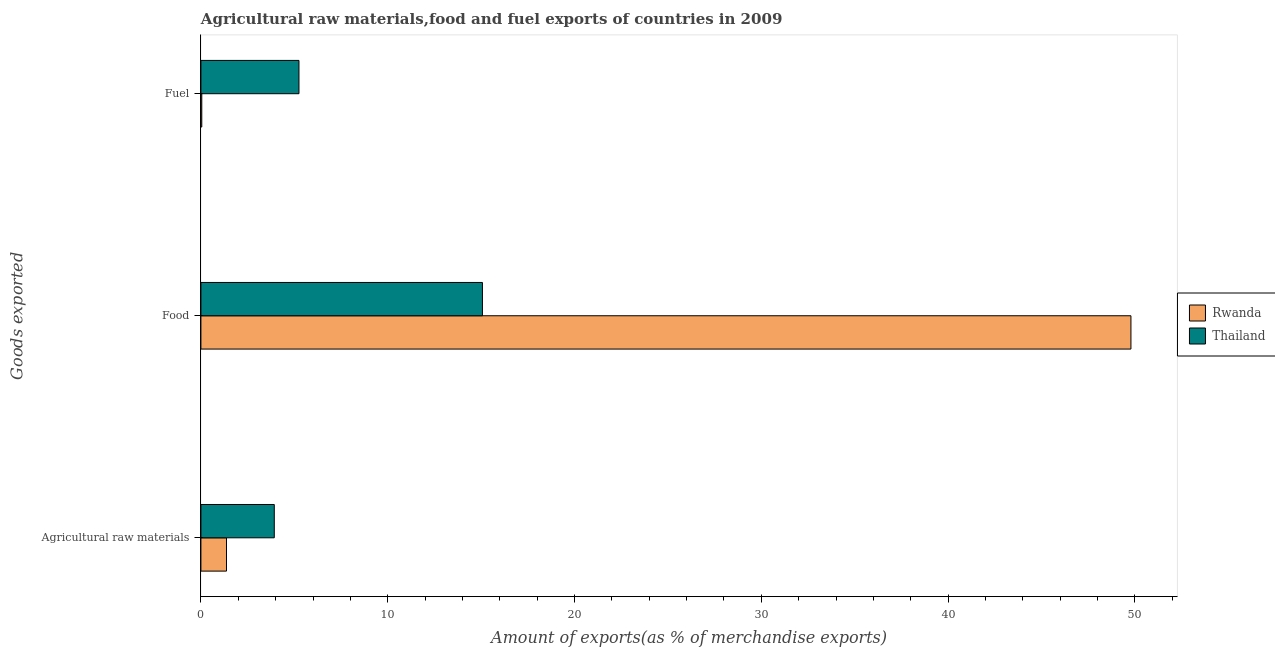How many different coloured bars are there?
Your answer should be very brief. 2. How many bars are there on the 2nd tick from the top?
Give a very brief answer. 2. How many bars are there on the 2nd tick from the bottom?
Offer a very short reply. 2. What is the label of the 1st group of bars from the top?
Keep it short and to the point. Fuel. What is the percentage of raw materials exports in Thailand?
Your response must be concise. 3.93. Across all countries, what is the maximum percentage of raw materials exports?
Ensure brevity in your answer.  3.93. Across all countries, what is the minimum percentage of food exports?
Provide a short and direct response. 15.07. In which country was the percentage of raw materials exports maximum?
Ensure brevity in your answer.  Thailand. In which country was the percentage of fuel exports minimum?
Offer a very short reply. Rwanda. What is the total percentage of food exports in the graph?
Ensure brevity in your answer.  64.86. What is the difference between the percentage of food exports in Rwanda and that in Thailand?
Your answer should be compact. 34.72. What is the difference between the percentage of raw materials exports in Rwanda and the percentage of food exports in Thailand?
Your answer should be compact. -13.7. What is the average percentage of fuel exports per country?
Keep it short and to the point. 2.65. What is the difference between the percentage of raw materials exports and percentage of fuel exports in Thailand?
Give a very brief answer. -1.32. In how many countries, is the percentage of food exports greater than 6 %?
Your response must be concise. 2. What is the ratio of the percentage of fuel exports in Rwanda to that in Thailand?
Keep it short and to the point. 0.01. Is the difference between the percentage of raw materials exports in Rwanda and Thailand greater than the difference between the percentage of food exports in Rwanda and Thailand?
Offer a very short reply. No. What is the difference between the highest and the second highest percentage of fuel exports?
Offer a very short reply. 5.2. What is the difference between the highest and the lowest percentage of raw materials exports?
Keep it short and to the point. 2.56. In how many countries, is the percentage of raw materials exports greater than the average percentage of raw materials exports taken over all countries?
Provide a succinct answer. 1. Is the sum of the percentage of fuel exports in Rwanda and Thailand greater than the maximum percentage of raw materials exports across all countries?
Give a very brief answer. Yes. What does the 1st bar from the top in Food represents?
Give a very brief answer. Thailand. What does the 2nd bar from the bottom in Fuel represents?
Make the answer very short. Thailand. Is it the case that in every country, the sum of the percentage of raw materials exports and percentage of food exports is greater than the percentage of fuel exports?
Provide a short and direct response. Yes. Are all the bars in the graph horizontal?
Offer a terse response. Yes. How many countries are there in the graph?
Your answer should be compact. 2. What is the difference between two consecutive major ticks on the X-axis?
Provide a succinct answer. 10. Does the graph contain any zero values?
Your response must be concise. No. Does the graph contain grids?
Offer a very short reply. No. How many legend labels are there?
Offer a very short reply. 2. How are the legend labels stacked?
Offer a terse response. Vertical. What is the title of the graph?
Offer a terse response. Agricultural raw materials,food and fuel exports of countries in 2009. What is the label or title of the X-axis?
Your answer should be very brief. Amount of exports(as % of merchandise exports). What is the label or title of the Y-axis?
Your answer should be compact. Goods exported. What is the Amount of exports(as % of merchandise exports) of Rwanda in Agricultural raw materials?
Offer a terse response. 1.37. What is the Amount of exports(as % of merchandise exports) of Thailand in Agricultural raw materials?
Offer a terse response. 3.93. What is the Amount of exports(as % of merchandise exports) in Rwanda in Food?
Offer a very short reply. 49.79. What is the Amount of exports(as % of merchandise exports) of Thailand in Food?
Make the answer very short. 15.07. What is the Amount of exports(as % of merchandise exports) of Rwanda in Fuel?
Offer a very short reply. 0.05. What is the Amount of exports(as % of merchandise exports) of Thailand in Fuel?
Your answer should be very brief. 5.25. Across all Goods exported, what is the maximum Amount of exports(as % of merchandise exports) in Rwanda?
Ensure brevity in your answer.  49.79. Across all Goods exported, what is the maximum Amount of exports(as % of merchandise exports) in Thailand?
Keep it short and to the point. 15.07. Across all Goods exported, what is the minimum Amount of exports(as % of merchandise exports) in Rwanda?
Make the answer very short. 0.05. Across all Goods exported, what is the minimum Amount of exports(as % of merchandise exports) in Thailand?
Provide a succinct answer. 3.93. What is the total Amount of exports(as % of merchandise exports) in Rwanda in the graph?
Provide a short and direct response. 51.2. What is the total Amount of exports(as % of merchandise exports) of Thailand in the graph?
Keep it short and to the point. 24.25. What is the difference between the Amount of exports(as % of merchandise exports) in Rwanda in Agricultural raw materials and that in Food?
Your answer should be very brief. -48.42. What is the difference between the Amount of exports(as % of merchandise exports) of Thailand in Agricultural raw materials and that in Food?
Offer a very short reply. -11.14. What is the difference between the Amount of exports(as % of merchandise exports) of Rwanda in Agricultural raw materials and that in Fuel?
Your response must be concise. 1.32. What is the difference between the Amount of exports(as % of merchandise exports) in Thailand in Agricultural raw materials and that in Fuel?
Keep it short and to the point. -1.32. What is the difference between the Amount of exports(as % of merchandise exports) of Rwanda in Food and that in Fuel?
Provide a succinct answer. 49.74. What is the difference between the Amount of exports(as % of merchandise exports) of Thailand in Food and that in Fuel?
Make the answer very short. 9.82. What is the difference between the Amount of exports(as % of merchandise exports) of Rwanda in Agricultural raw materials and the Amount of exports(as % of merchandise exports) of Thailand in Food?
Offer a very short reply. -13.7. What is the difference between the Amount of exports(as % of merchandise exports) in Rwanda in Agricultural raw materials and the Amount of exports(as % of merchandise exports) in Thailand in Fuel?
Make the answer very short. -3.88. What is the difference between the Amount of exports(as % of merchandise exports) of Rwanda in Food and the Amount of exports(as % of merchandise exports) of Thailand in Fuel?
Give a very brief answer. 44.54. What is the average Amount of exports(as % of merchandise exports) of Rwanda per Goods exported?
Your answer should be very brief. 17.07. What is the average Amount of exports(as % of merchandise exports) of Thailand per Goods exported?
Make the answer very short. 8.08. What is the difference between the Amount of exports(as % of merchandise exports) of Rwanda and Amount of exports(as % of merchandise exports) of Thailand in Agricultural raw materials?
Ensure brevity in your answer.  -2.56. What is the difference between the Amount of exports(as % of merchandise exports) of Rwanda and Amount of exports(as % of merchandise exports) of Thailand in Food?
Give a very brief answer. 34.72. What is the difference between the Amount of exports(as % of merchandise exports) in Rwanda and Amount of exports(as % of merchandise exports) in Thailand in Fuel?
Offer a terse response. -5.2. What is the ratio of the Amount of exports(as % of merchandise exports) of Rwanda in Agricultural raw materials to that in Food?
Your answer should be compact. 0.03. What is the ratio of the Amount of exports(as % of merchandise exports) of Thailand in Agricultural raw materials to that in Food?
Your answer should be very brief. 0.26. What is the ratio of the Amount of exports(as % of merchandise exports) of Rwanda in Agricultural raw materials to that in Fuel?
Ensure brevity in your answer.  29.34. What is the ratio of the Amount of exports(as % of merchandise exports) of Thailand in Agricultural raw materials to that in Fuel?
Provide a succinct answer. 0.75. What is the ratio of the Amount of exports(as % of merchandise exports) in Rwanda in Food to that in Fuel?
Your answer should be compact. 1066.36. What is the ratio of the Amount of exports(as % of merchandise exports) of Thailand in Food to that in Fuel?
Keep it short and to the point. 2.87. What is the difference between the highest and the second highest Amount of exports(as % of merchandise exports) of Rwanda?
Your answer should be very brief. 48.42. What is the difference between the highest and the second highest Amount of exports(as % of merchandise exports) of Thailand?
Provide a succinct answer. 9.82. What is the difference between the highest and the lowest Amount of exports(as % of merchandise exports) of Rwanda?
Ensure brevity in your answer.  49.74. What is the difference between the highest and the lowest Amount of exports(as % of merchandise exports) of Thailand?
Provide a succinct answer. 11.14. 